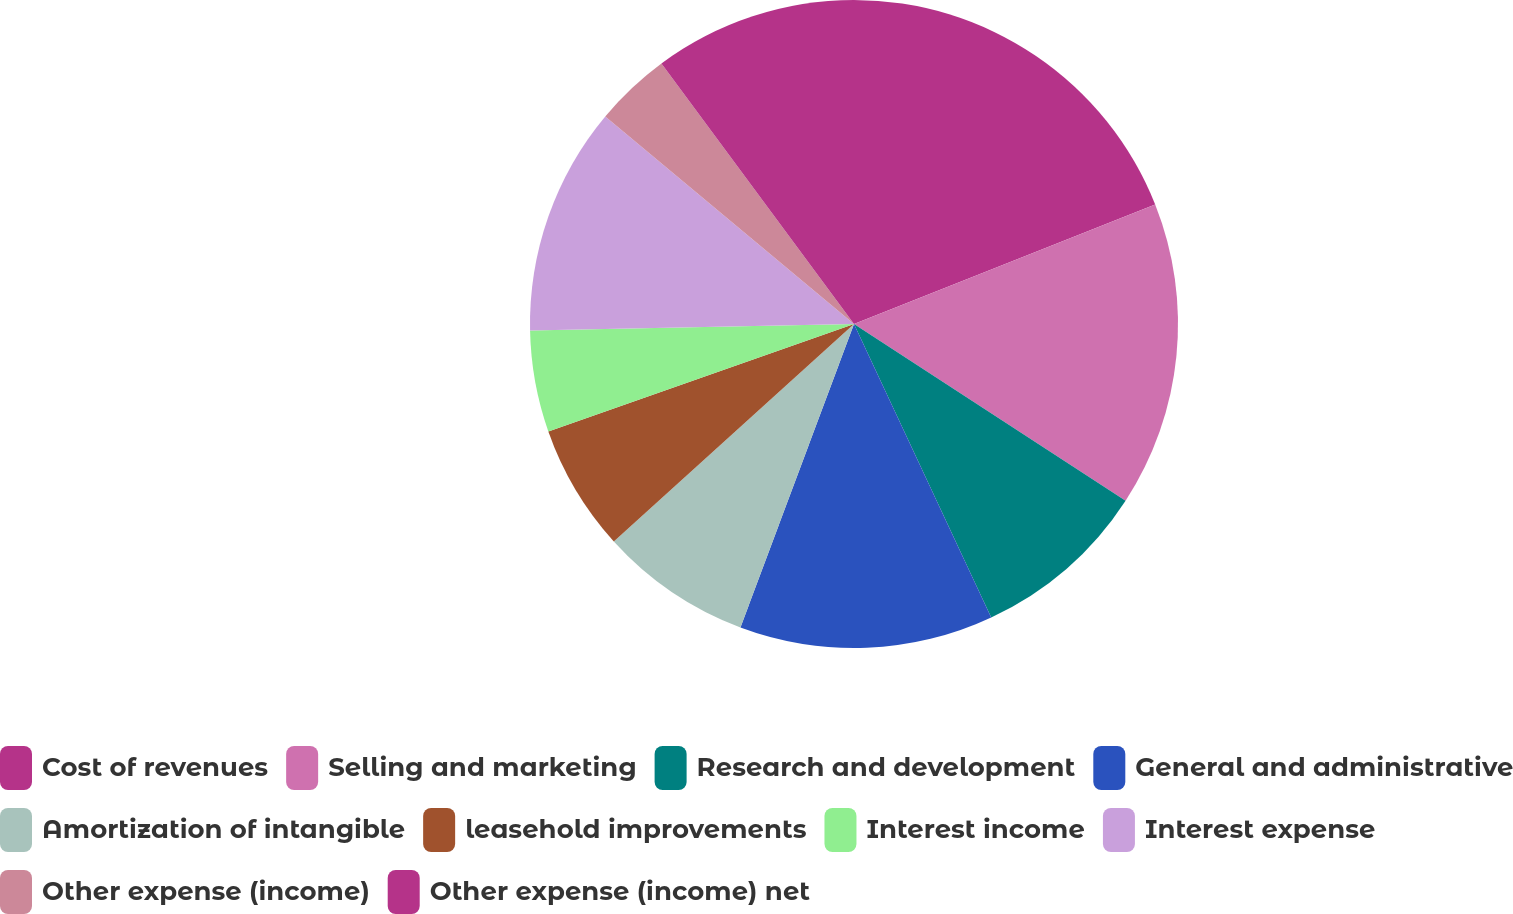Convert chart to OTSL. <chart><loc_0><loc_0><loc_500><loc_500><pie_chart><fcel>Cost of revenues<fcel>Selling and marketing<fcel>Research and development<fcel>General and administrative<fcel>Amortization of intangible<fcel>leasehold improvements<fcel>Interest income<fcel>Interest expense<fcel>Other expense (income)<fcel>Other expense (income) net<nl><fcel>18.99%<fcel>15.19%<fcel>8.86%<fcel>12.66%<fcel>7.59%<fcel>6.33%<fcel>5.06%<fcel>11.39%<fcel>3.8%<fcel>10.13%<nl></chart> 